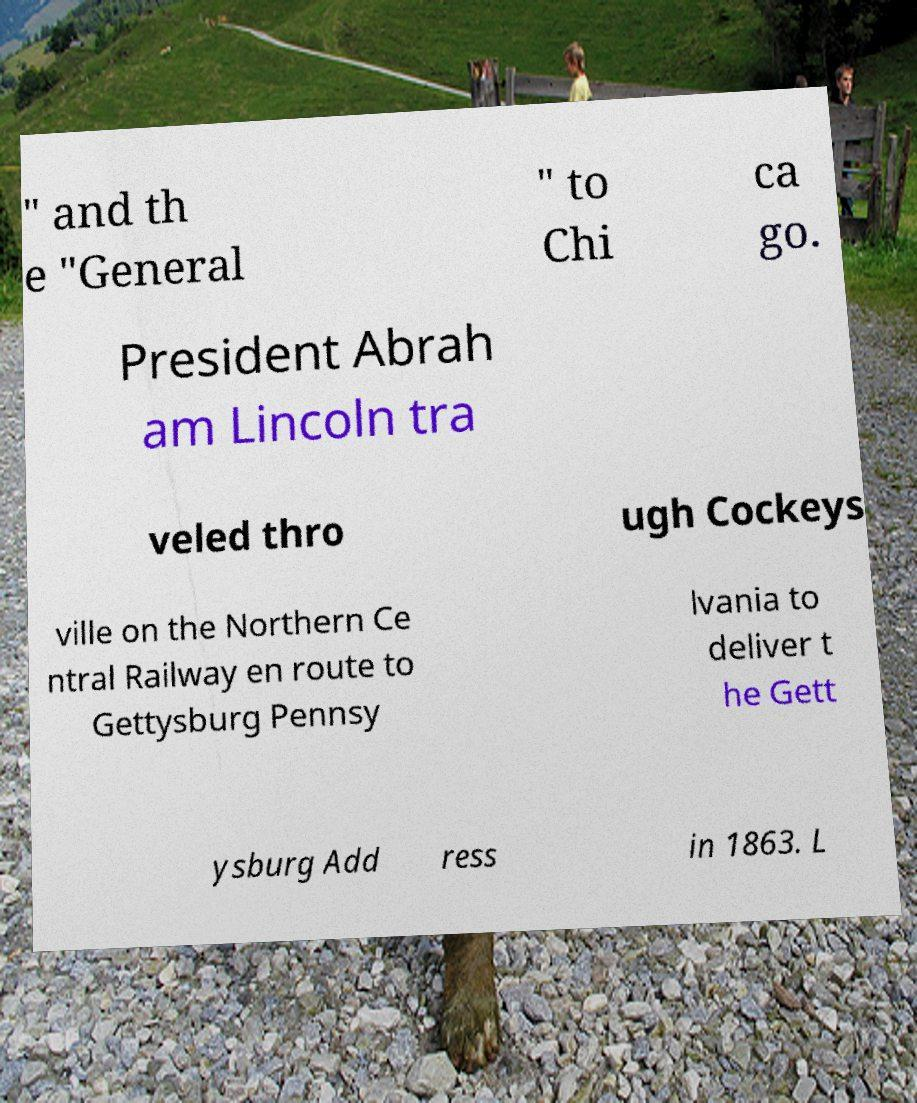I need the written content from this picture converted into text. Can you do that? " and th e "General " to Chi ca go. President Abrah am Lincoln tra veled thro ugh Cockeys ville on the Northern Ce ntral Railway en route to Gettysburg Pennsy lvania to deliver t he Gett ysburg Add ress in 1863. L 